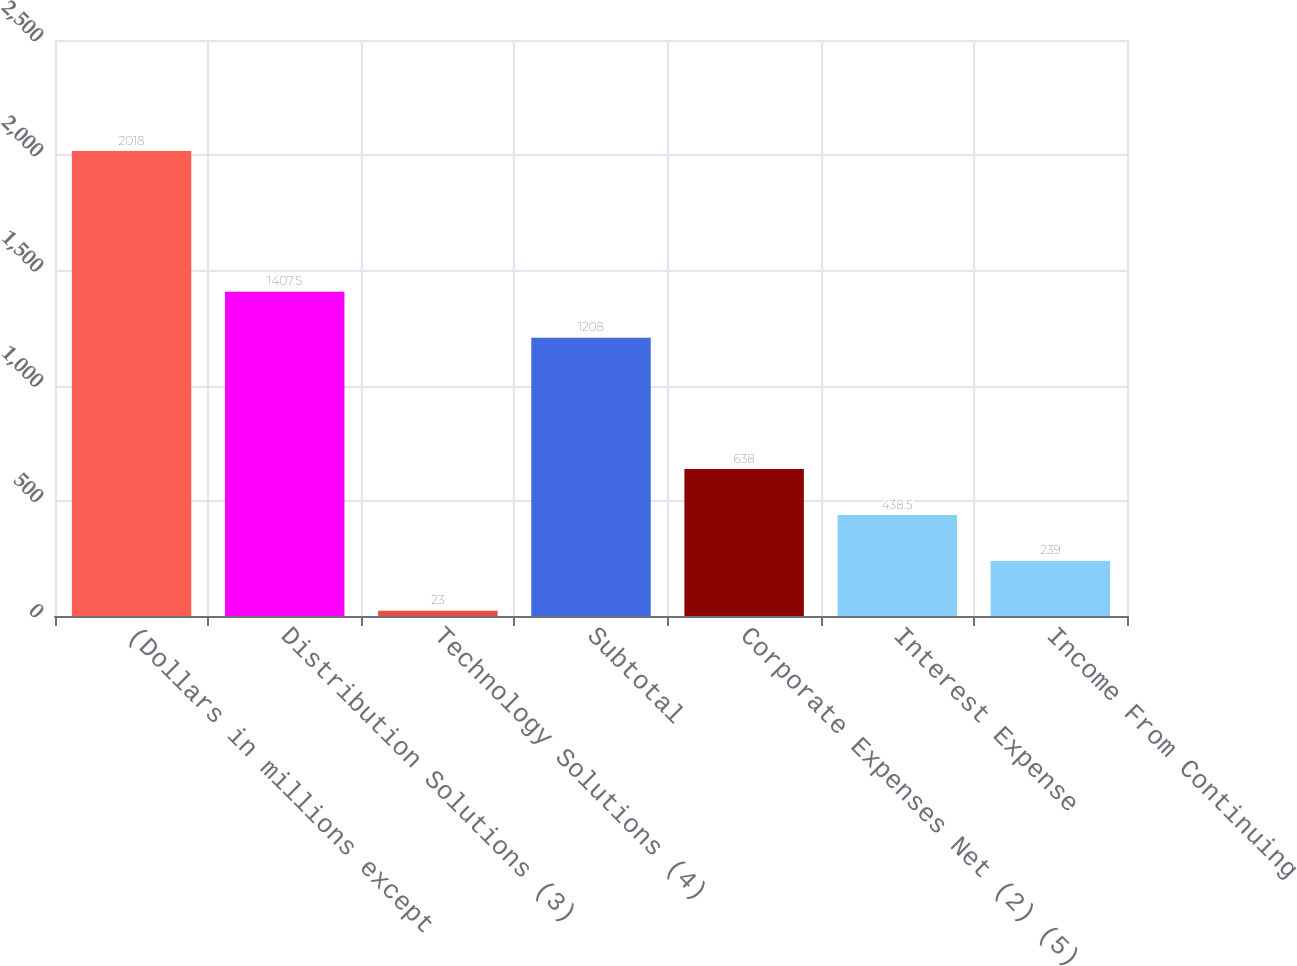Convert chart. <chart><loc_0><loc_0><loc_500><loc_500><bar_chart><fcel>(Dollars in millions except<fcel>Distribution Solutions (3)<fcel>Technology Solutions (4)<fcel>Subtotal<fcel>Corporate Expenses Net (2) (5)<fcel>Interest Expense<fcel>Income From Continuing<nl><fcel>2018<fcel>1407.5<fcel>23<fcel>1208<fcel>638<fcel>438.5<fcel>239<nl></chart> 